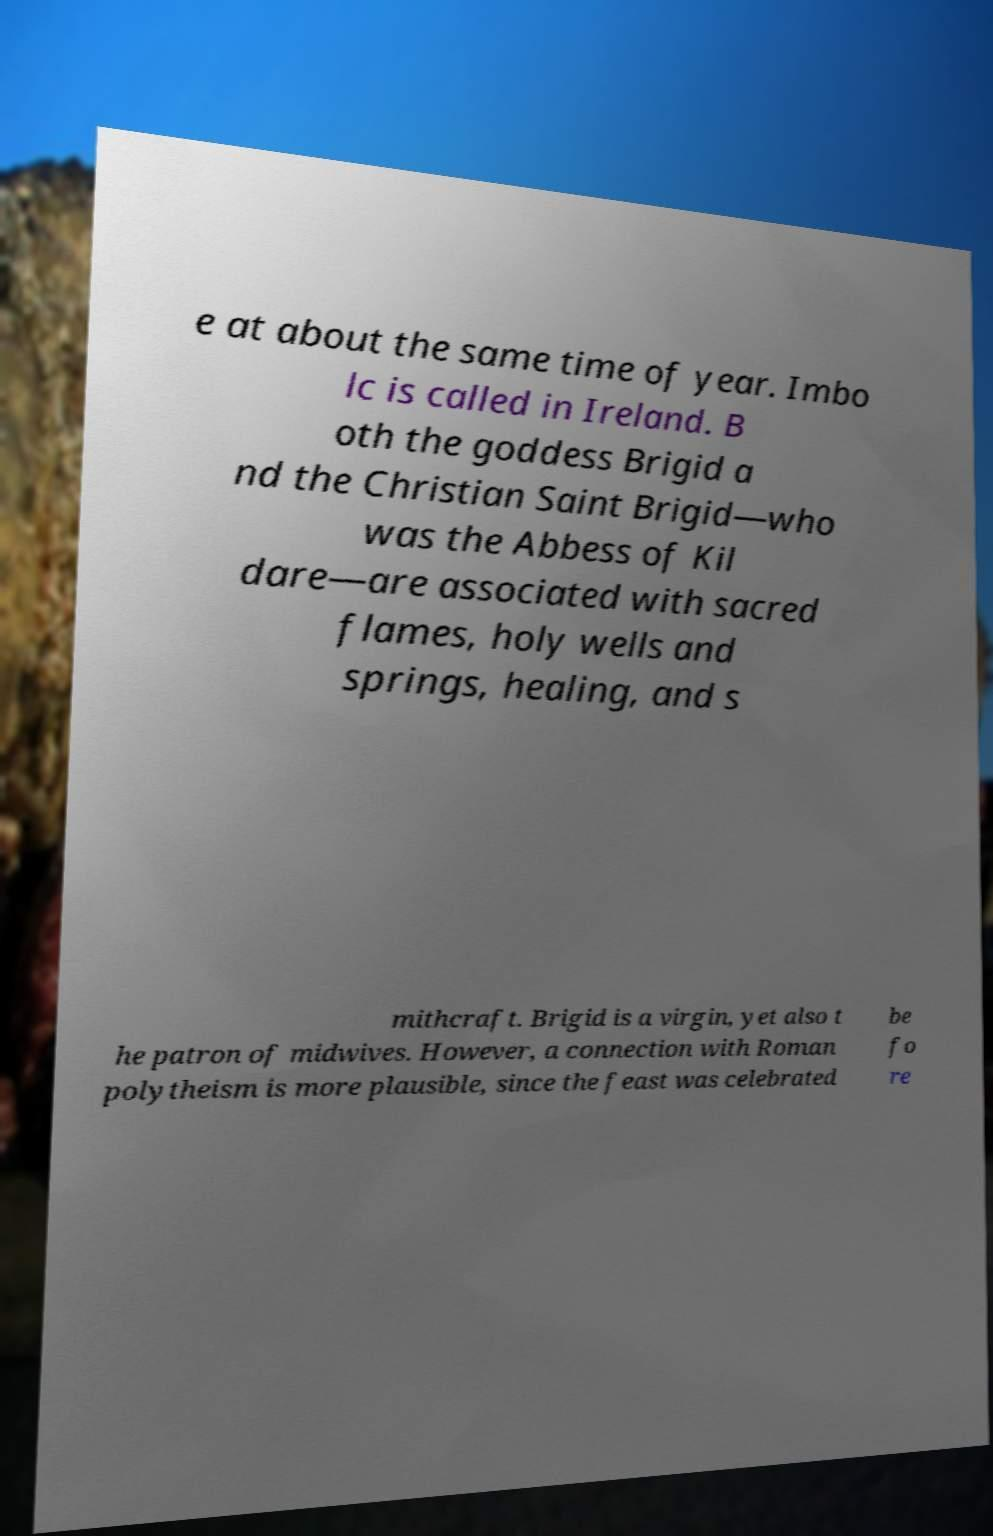I need the written content from this picture converted into text. Can you do that? e at about the same time of year. Imbo lc is called in Ireland. B oth the goddess Brigid a nd the Christian Saint Brigid—who was the Abbess of Kil dare—are associated with sacred flames, holy wells and springs, healing, and s mithcraft. Brigid is a virgin, yet also t he patron of midwives. However, a connection with Roman polytheism is more plausible, since the feast was celebrated be fo re 